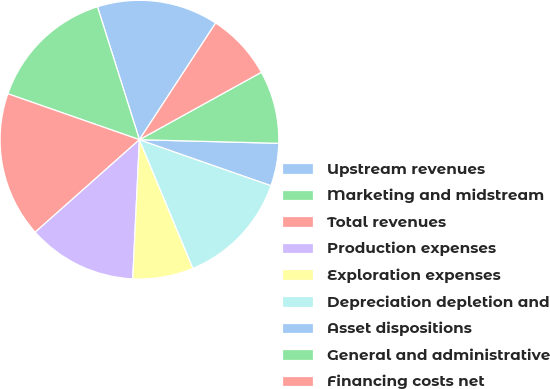<chart> <loc_0><loc_0><loc_500><loc_500><pie_chart><fcel>Upstream revenues<fcel>Marketing and midstream<fcel>Total revenues<fcel>Production expenses<fcel>Exploration expenses<fcel>Depreciation depletion and<fcel>Asset dispositions<fcel>General and administrative<fcel>Financing costs net<nl><fcel>14.08%<fcel>14.79%<fcel>16.9%<fcel>12.68%<fcel>7.04%<fcel>13.38%<fcel>4.93%<fcel>8.45%<fcel>7.75%<nl></chart> 